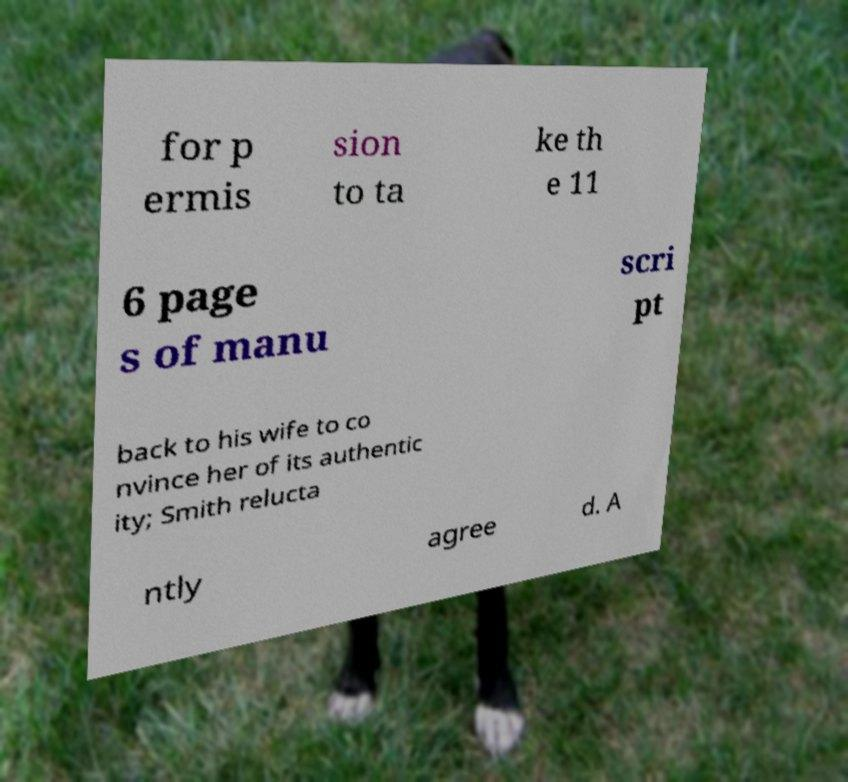Can you accurately transcribe the text from the provided image for me? for p ermis sion to ta ke th e 11 6 page s of manu scri pt back to his wife to co nvince her of its authentic ity; Smith relucta ntly agree d. A 